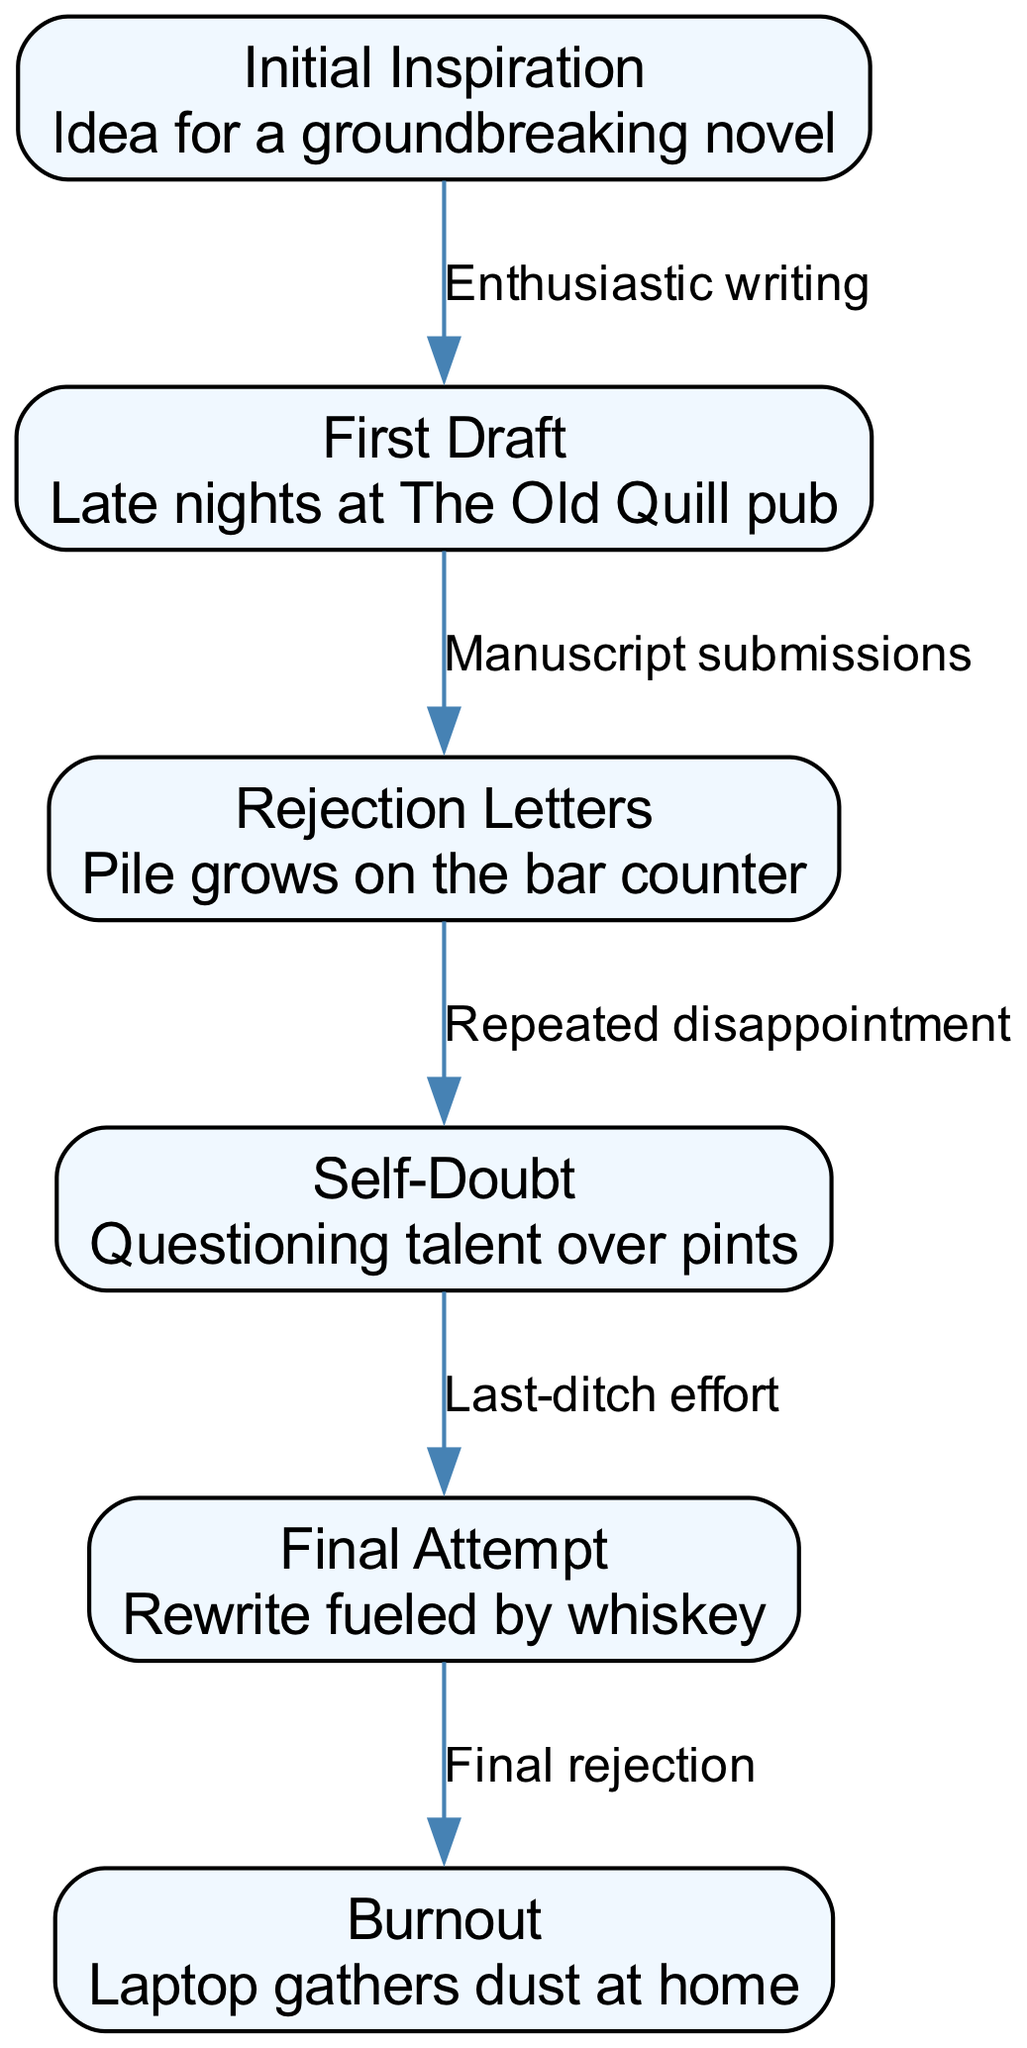What is the first stage of disillusionment in a writer's career? The first stage in the diagram is labeled "Initial Inspiration," which represents the starting point where the idea for a groundbreaking novel emerges.
Answer: Initial Inspiration How many nodes are in the diagram? To find the number of nodes, we count each unique labeled box in the diagram. There are six nodes representing various stages.
Answer: 6 What stage follows "Rejection Letters"? In the flow of the diagram, "Rejection Letters" is connected to "Self-Doubt," indicating that it is the next stage that a writer experiences after accumulating rejection letters for their submissions.
Answer: Self-Doubt What is the final outcome after "Final Attempt"? The flow from "Final Attempt" leads to "Burnout," suggesting that after making a last effort in their writing journey, the culmination of their experiences results in burnout.
Answer: Burnout What type of effort is made before the "Final Attempt"? The diagram indicates a "Last-ditch effort" is made preceding the "Final Attempt," emphasizing the urgency and desperation at that stage.
Answer: Last-ditch effort How does "First Draft" relate to "Rejection Letters"? The connection labeled "Manuscript submissions" shows that the "First Draft" leads to "Rejection Letters," illustrating the process of submitting the draft and subsequently receiving rejections.
Answer: Manuscript submissions Which node describes questioning talent over pints? The node labeled "Self-Doubt" captures the essence of questioning one's talent, specifically conveying that this process occurs while enjoying pints, likely as a moment of reflection in a pub setting.
Answer: Self-Doubt What is the emotional transition represented from "Rejection Letters" to "Self-Doubt"? The relationship labeled "Repeated disappointment" illustrates the emotional transition of the writer from accumulating rejection letters to experiencing self-doubt as a result of those disappointments.
Answer: Repeated disappointment 